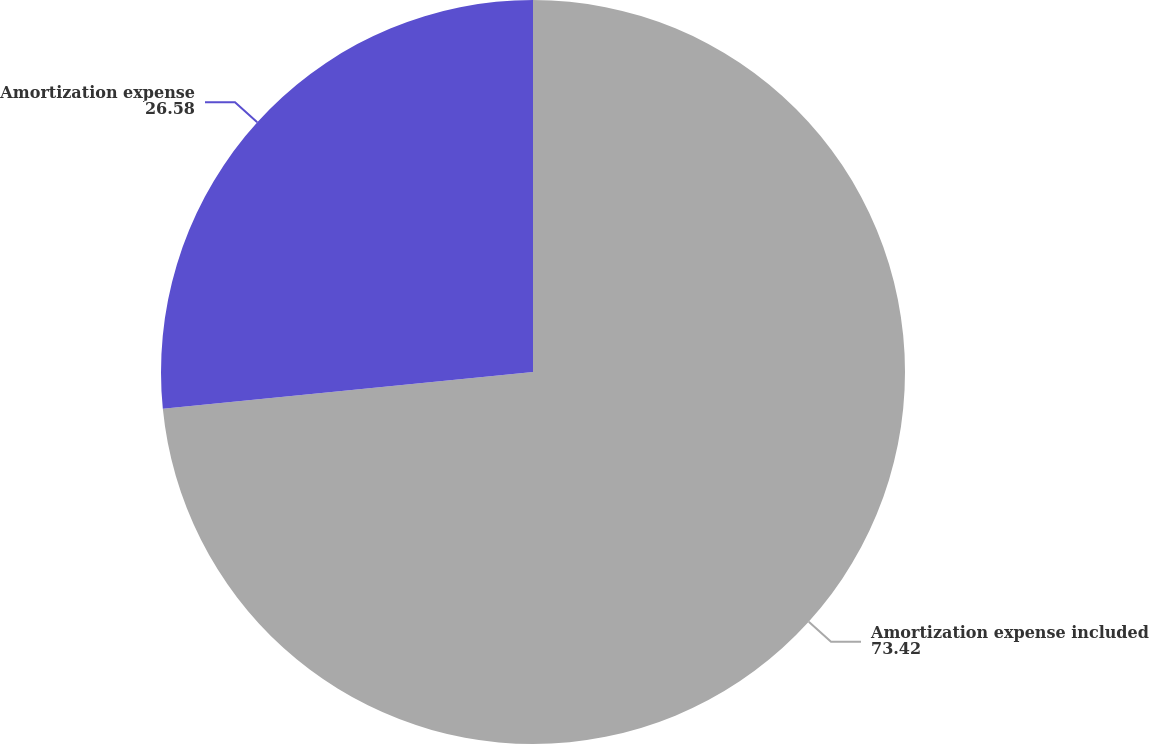Convert chart to OTSL. <chart><loc_0><loc_0><loc_500><loc_500><pie_chart><fcel>Amortization expense included<fcel>Amortization expense<nl><fcel>73.42%<fcel>26.58%<nl></chart> 